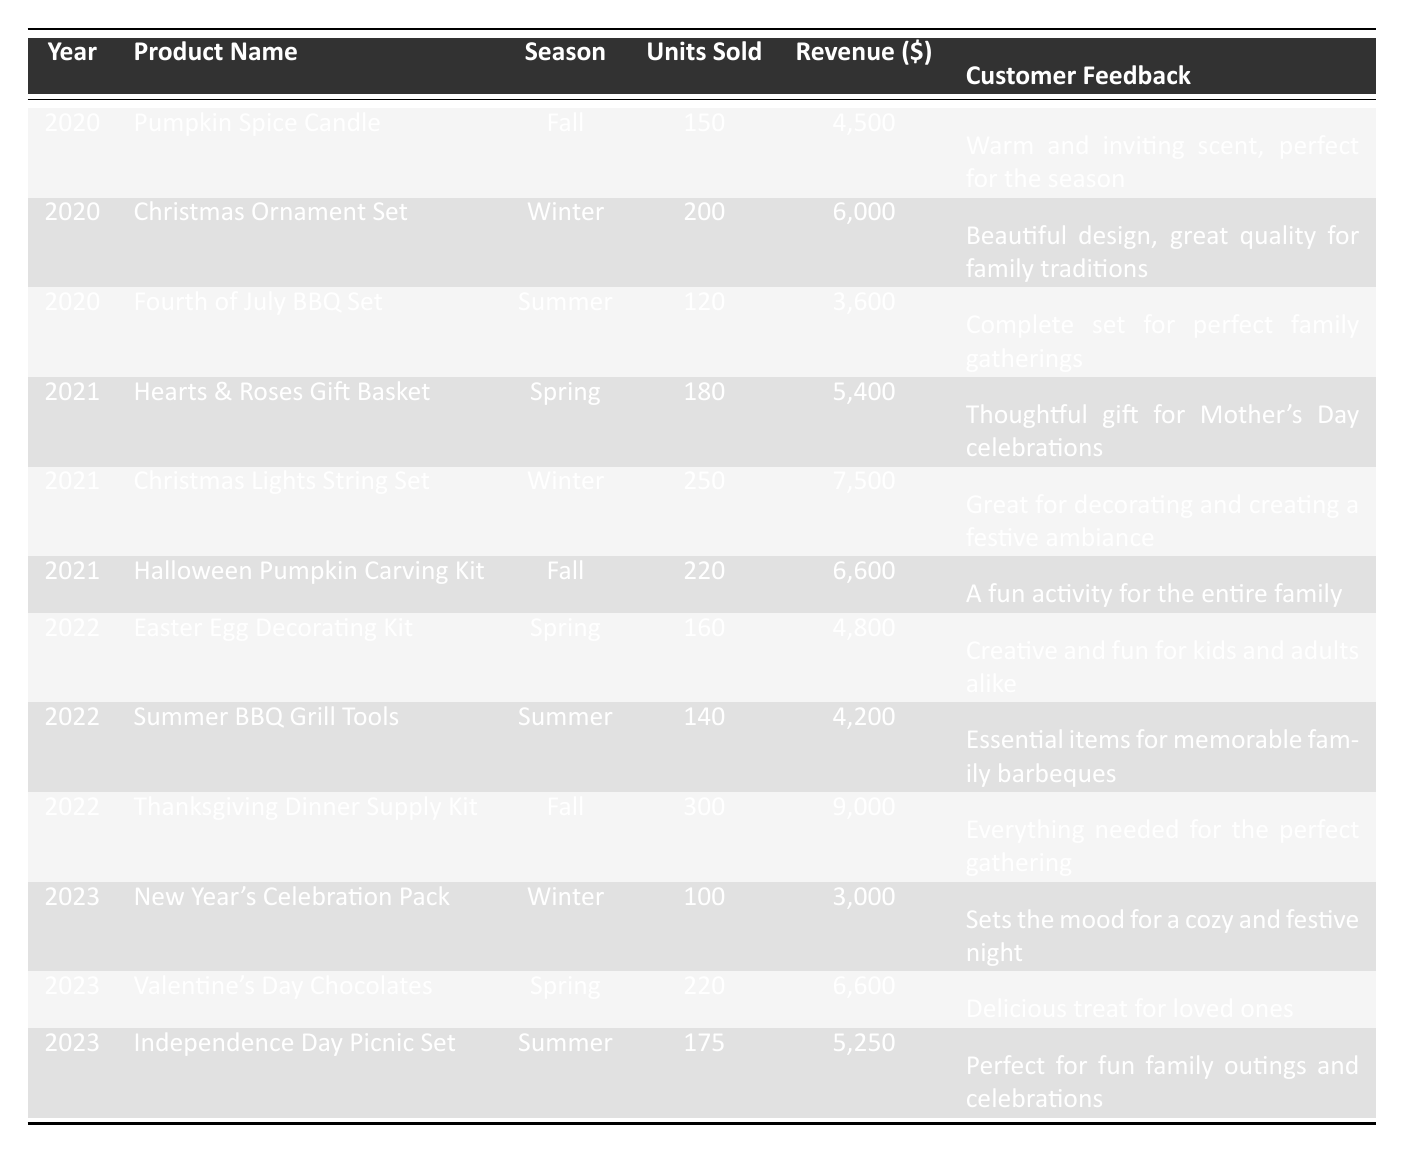What is the total revenue generated from the Thanksgiving Dinner Supply Kit? The Thanksgiving Dinner Supply Kit has a revenue of $9,000, as indicated in the table.
Answer: $9,000 In which season did the Hearts & Roses Gift Basket sell the highest number of units? The Hearts & Roses Gift Basket, sold in Spring 2021, had units sold equal to 180, which is higher than any other seasonal product in that year.
Answer: Spring What is the average number of units sold for products released in Summer? To find the average, we sum the units sold for all summer products: 120 (Fourth of July BBQ Set) + 140 (Summer BBQ Grill Tools) + 175 (Independence Day Picnic Set) = 435. There are 3 summer products, so the average is 435/3 = 145.
Answer: 145 Is the customer feedback for the Christmas Lights String Set positive? The feedback states, "Great for decorating and creating a festive ambiance," which indicates a positive sentiment.
Answer: Yes Which product generated the highest revenue in 2022? The product with the highest revenue in 2022 is the Thanksgiving Dinner Supply Kit, generating $9,000.
Answer: Thanksgiving Dinner Supply Kit What is the total number of units sold across all Fall products from 2020, 2021, and 2022? The units sold for Fall products are 150 (Pumpkin Spice Candle, 2020) + 220 (Halloween Pumpkin Carving Kit, 2021) + 300 (Thanksgiving Dinner Supply Kit, 2022) = 670.
Answer: 670 How many units of Valentine's Day Chocolates were sold compared to New Year's Celebration Pack in 2023? Valentine's Day Chocolates sold 220 units, while the New Year's Celebration Pack sold 100 units. The difference is 220 - 100 = 120 more units sold for Valentine's Day Chocolates.
Answer: 120 more What appears to be the main theme of customer feedback for holiday products? Upon reviewing the feedback for holiday products, the sentiment focuses on creating a warm, festive atmosphere and enhancing family gatherings, suggesting a positive emotional connection.
Answer: Creating a festive atmosphere Which year had the highest total revenue from Spring products? The Spring products generated revenue of $5,400 (Hearts & Roses Gift Basket, 2021) + $4,800 (Easter Egg Decorating Kit, 2022) + $6,600 (Valentine's Day Chocolates, 2023) for a total of $16,800. Thus, 2023 has the highest spring revenue.
Answer: 2023 How does the revenue from Winter products in 2021 compare to Winter products in 2023? In 2021, Winter products generated $7,500 (Christmas Lights String Set) compared to $3,000 (New Year's Celebration Pack) in 2023. The difference is $7,500 - $3,000 = $4,500; therefore, 2021 had a higher revenue.
Answer: 2021 had higher revenue by $4,500 